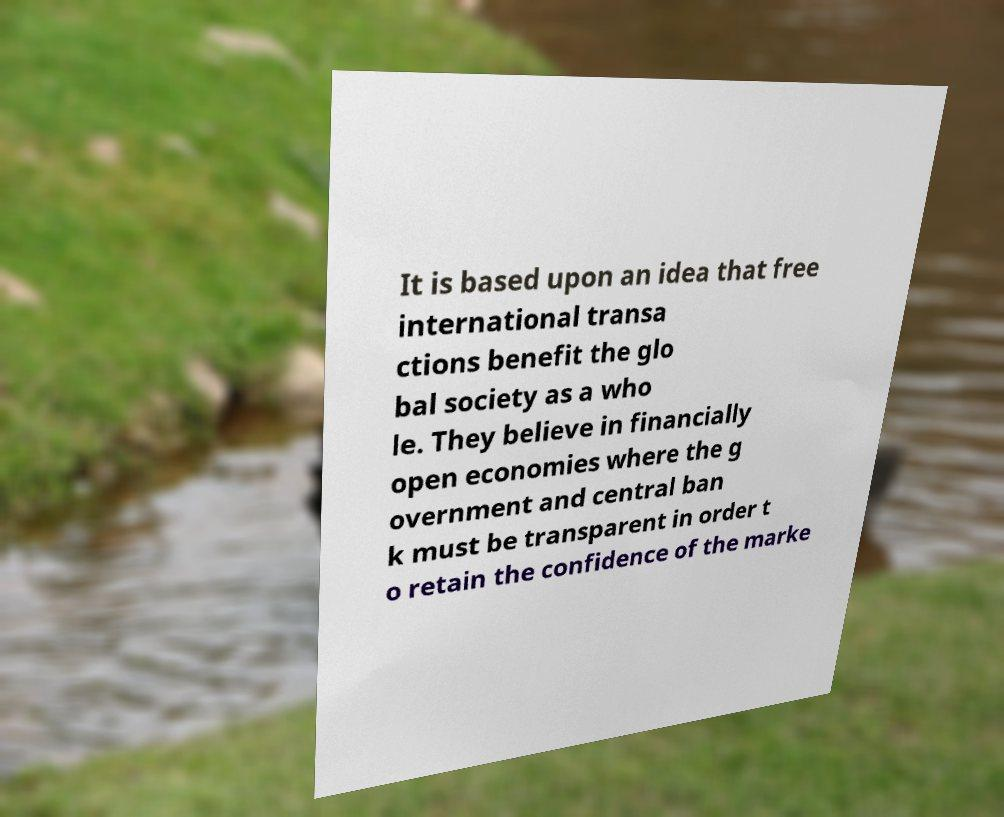What messages or text are displayed in this image? I need them in a readable, typed format. It is based upon an idea that free international transa ctions benefit the glo bal society as a who le. They believe in financially open economies where the g overnment and central ban k must be transparent in order t o retain the confidence of the marke 